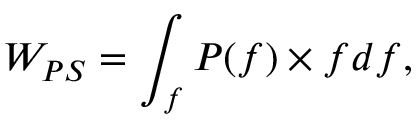<formula> <loc_0><loc_0><loc_500><loc_500>W _ { P S } = \int _ { f } P ( f ) \times f d f ,</formula> 